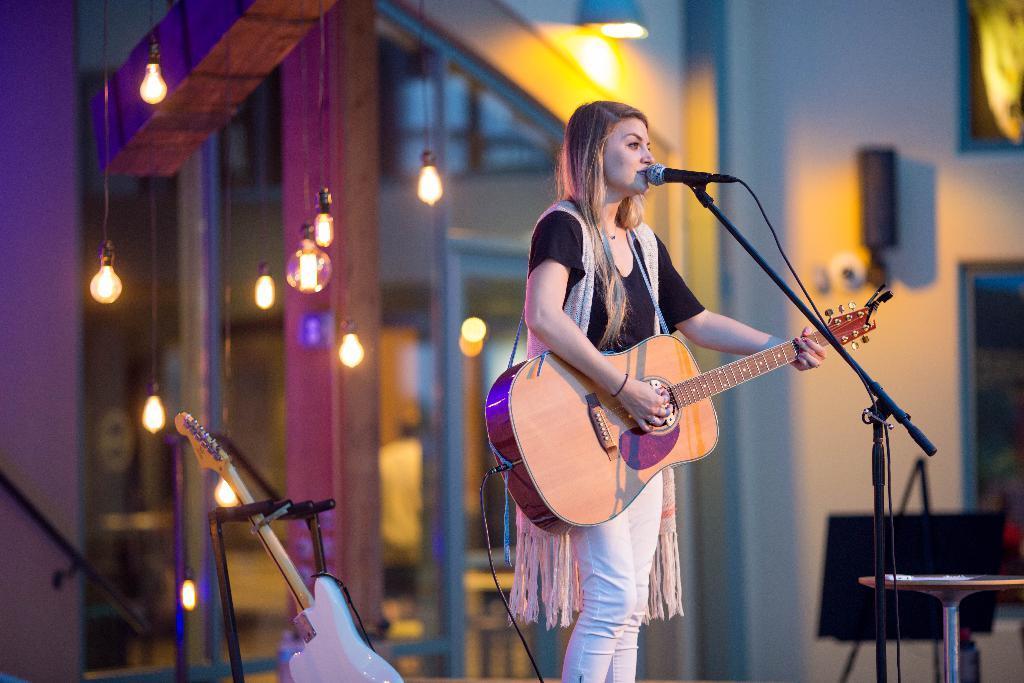Could you give a brief overview of what you see in this image? In this image I see a woman who is standing in front of a mic and she is holding a guitar, I can also there is another guitar over here. In the background I see the lights and the wall. 